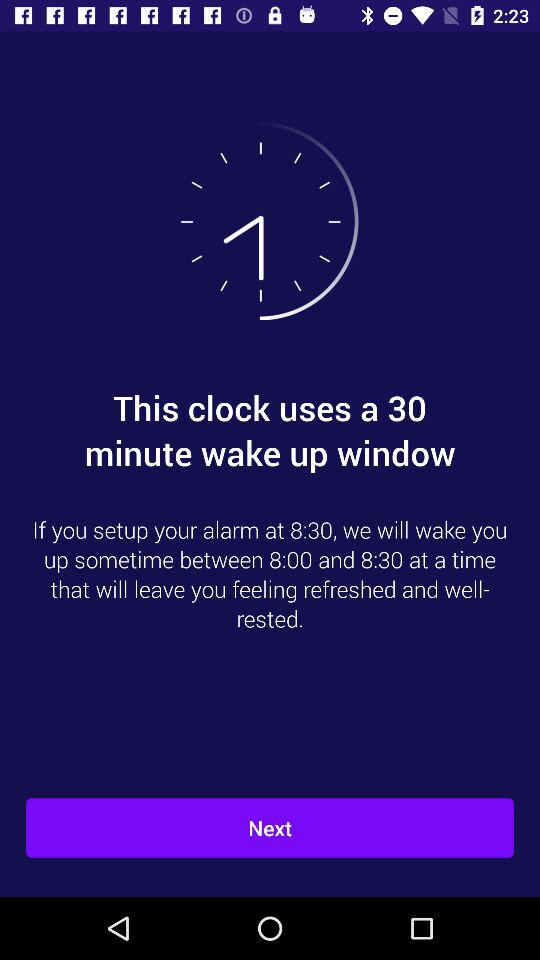What is the difference between the maximum and minimum wake up times?
Answer the question using a single word or phrase. 30 minutes 